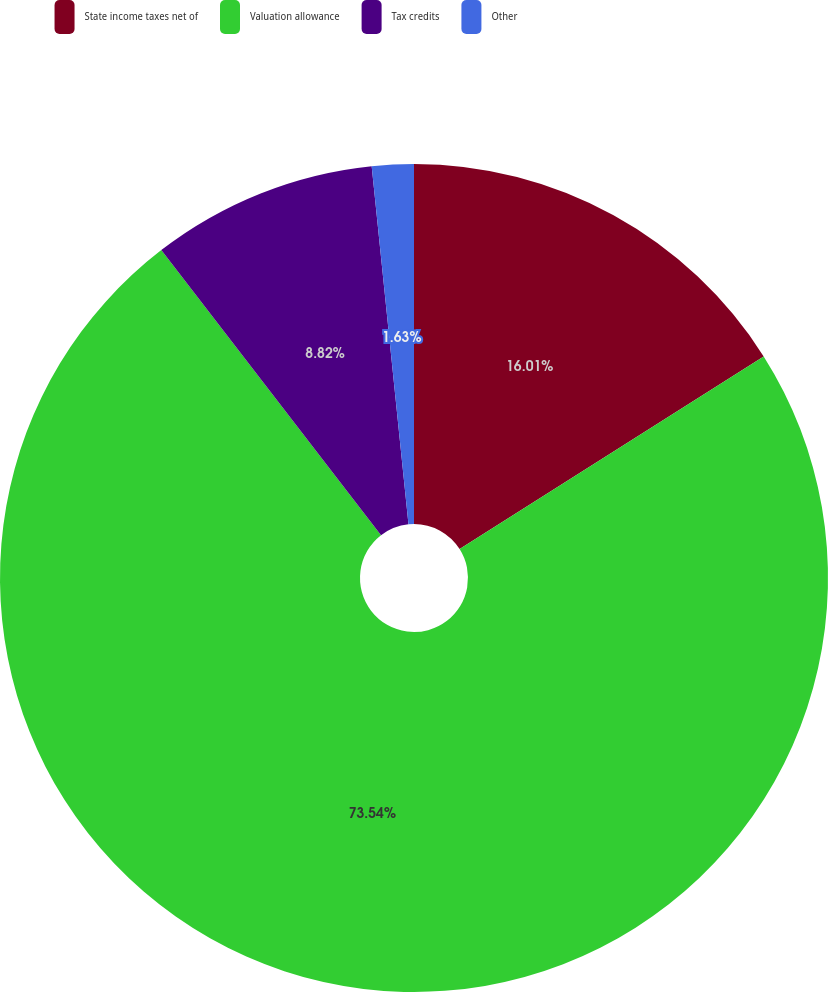<chart> <loc_0><loc_0><loc_500><loc_500><pie_chart><fcel>State income taxes net of<fcel>Valuation allowance<fcel>Tax credits<fcel>Other<nl><fcel>16.01%<fcel>73.54%<fcel>8.82%<fcel>1.63%<nl></chart> 